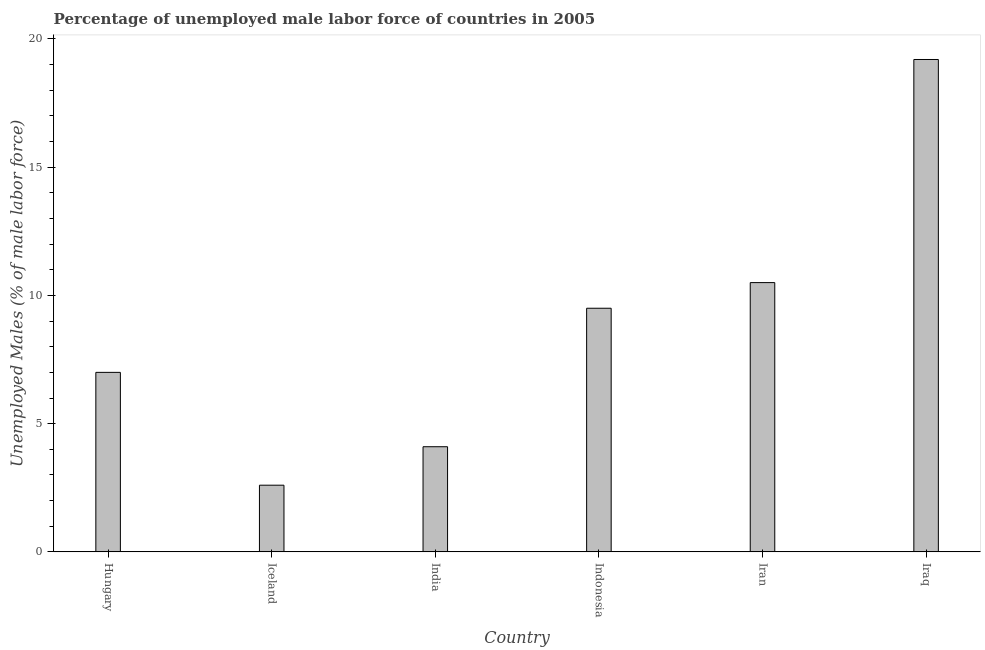What is the title of the graph?
Offer a terse response. Percentage of unemployed male labor force of countries in 2005. What is the label or title of the Y-axis?
Your answer should be very brief. Unemployed Males (% of male labor force). What is the total unemployed male labour force in Iran?
Ensure brevity in your answer.  10.5. Across all countries, what is the maximum total unemployed male labour force?
Offer a terse response. 19.2. Across all countries, what is the minimum total unemployed male labour force?
Offer a very short reply. 2.6. In which country was the total unemployed male labour force maximum?
Keep it short and to the point. Iraq. In which country was the total unemployed male labour force minimum?
Offer a terse response. Iceland. What is the sum of the total unemployed male labour force?
Ensure brevity in your answer.  52.9. What is the difference between the total unemployed male labour force in Iran and Iraq?
Your response must be concise. -8.7. What is the average total unemployed male labour force per country?
Make the answer very short. 8.82. What is the median total unemployed male labour force?
Keep it short and to the point. 8.25. In how many countries, is the total unemployed male labour force greater than 15 %?
Ensure brevity in your answer.  1. What is the ratio of the total unemployed male labour force in India to that in Iraq?
Keep it short and to the point. 0.21. Is the total unemployed male labour force in Hungary less than that in Indonesia?
Offer a terse response. Yes. Is the difference between the total unemployed male labour force in Iceland and India greater than the difference between any two countries?
Offer a terse response. No. Is the sum of the total unemployed male labour force in India and Iran greater than the maximum total unemployed male labour force across all countries?
Your answer should be compact. No. In how many countries, is the total unemployed male labour force greater than the average total unemployed male labour force taken over all countries?
Offer a terse response. 3. How many countries are there in the graph?
Offer a very short reply. 6. What is the difference between two consecutive major ticks on the Y-axis?
Your response must be concise. 5. Are the values on the major ticks of Y-axis written in scientific E-notation?
Your response must be concise. No. What is the Unemployed Males (% of male labor force) in Iceland?
Offer a terse response. 2.6. What is the Unemployed Males (% of male labor force) in India?
Keep it short and to the point. 4.1. What is the Unemployed Males (% of male labor force) in Indonesia?
Provide a succinct answer. 9.5. What is the Unemployed Males (% of male labor force) in Iran?
Provide a short and direct response. 10.5. What is the Unemployed Males (% of male labor force) in Iraq?
Ensure brevity in your answer.  19.2. What is the difference between the Unemployed Males (% of male labor force) in Hungary and Iran?
Your answer should be very brief. -3.5. What is the difference between the Unemployed Males (% of male labor force) in Hungary and Iraq?
Offer a very short reply. -12.2. What is the difference between the Unemployed Males (% of male labor force) in Iceland and Indonesia?
Your answer should be very brief. -6.9. What is the difference between the Unemployed Males (% of male labor force) in Iceland and Iran?
Offer a very short reply. -7.9. What is the difference between the Unemployed Males (% of male labor force) in Iceland and Iraq?
Your response must be concise. -16.6. What is the difference between the Unemployed Males (% of male labor force) in India and Iran?
Make the answer very short. -6.4. What is the difference between the Unemployed Males (% of male labor force) in India and Iraq?
Make the answer very short. -15.1. What is the difference between the Unemployed Males (% of male labor force) in Indonesia and Iran?
Your response must be concise. -1. What is the ratio of the Unemployed Males (% of male labor force) in Hungary to that in Iceland?
Your response must be concise. 2.69. What is the ratio of the Unemployed Males (% of male labor force) in Hungary to that in India?
Offer a very short reply. 1.71. What is the ratio of the Unemployed Males (% of male labor force) in Hungary to that in Indonesia?
Your response must be concise. 0.74. What is the ratio of the Unemployed Males (% of male labor force) in Hungary to that in Iran?
Make the answer very short. 0.67. What is the ratio of the Unemployed Males (% of male labor force) in Hungary to that in Iraq?
Make the answer very short. 0.36. What is the ratio of the Unemployed Males (% of male labor force) in Iceland to that in India?
Your response must be concise. 0.63. What is the ratio of the Unemployed Males (% of male labor force) in Iceland to that in Indonesia?
Make the answer very short. 0.27. What is the ratio of the Unemployed Males (% of male labor force) in Iceland to that in Iran?
Make the answer very short. 0.25. What is the ratio of the Unemployed Males (% of male labor force) in Iceland to that in Iraq?
Offer a terse response. 0.14. What is the ratio of the Unemployed Males (% of male labor force) in India to that in Indonesia?
Your answer should be compact. 0.43. What is the ratio of the Unemployed Males (% of male labor force) in India to that in Iran?
Your answer should be very brief. 0.39. What is the ratio of the Unemployed Males (% of male labor force) in India to that in Iraq?
Keep it short and to the point. 0.21. What is the ratio of the Unemployed Males (% of male labor force) in Indonesia to that in Iran?
Keep it short and to the point. 0.91. What is the ratio of the Unemployed Males (% of male labor force) in Indonesia to that in Iraq?
Offer a very short reply. 0.49. What is the ratio of the Unemployed Males (% of male labor force) in Iran to that in Iraq?
Keep it short and to the point. 0.55. 